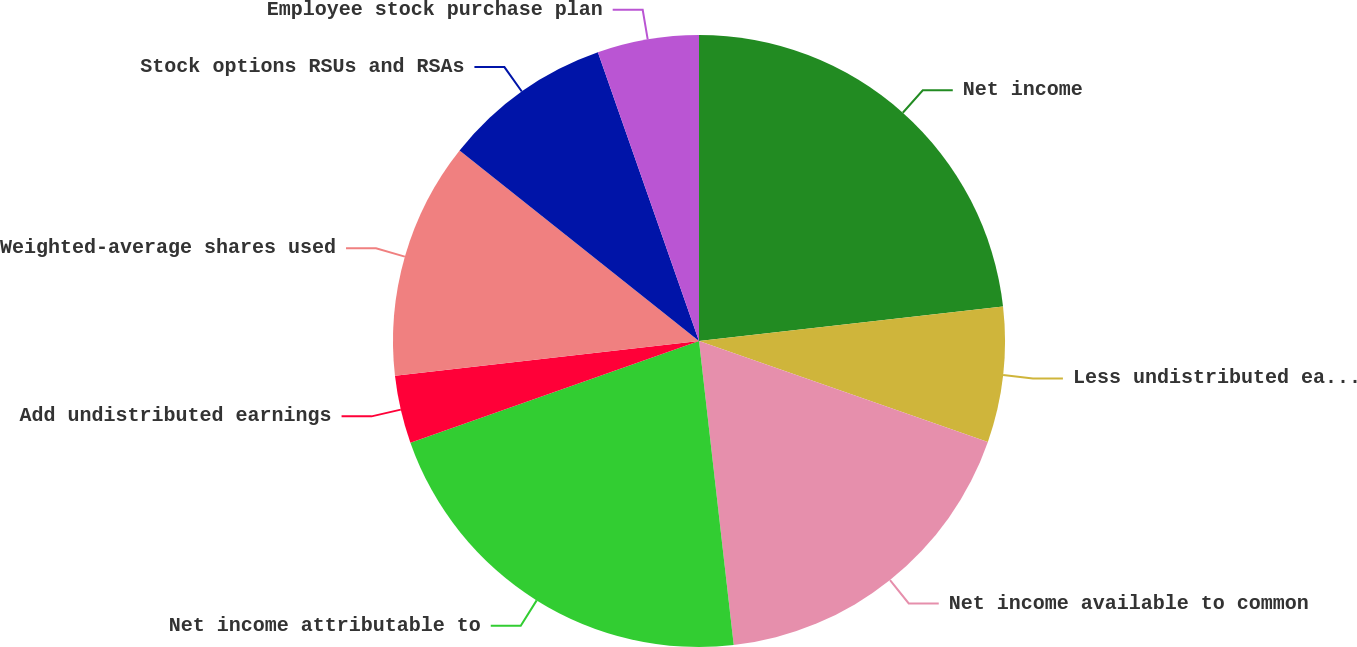Convert chart. <chart><loc_0><loc_0><loc_500><loc_500><pie_chart><fcel>Net income<fcel>Less undistributed earnings<fcel>Net income available to common<fcel>Net income attributable to<fcel>Add undistributed earnings<fcel>Weighted-average shares used<fcel>Stock options RSUs and RSAs<fcel>Employee stock purchase plan<nl><fcel>23.2%<fcel>7.15%<fcel>17.84%<fcel>21.42%<fcel>3.58%<fcel>12.51%<fcel>8.94%<fcel>5.36%<nl></chart> 